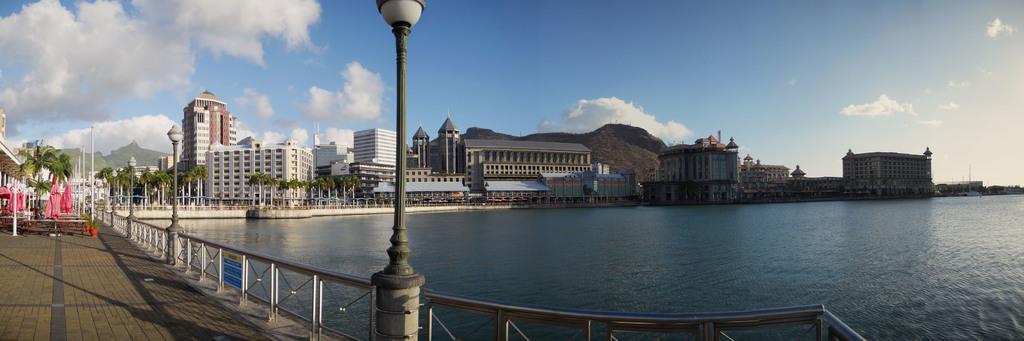Please provide a concise description of this image. In this picture there is a bridge with iron railing and lamp post. Behind there is a river water. In the background there are some buildings and above we can see blue sky and clouds. 